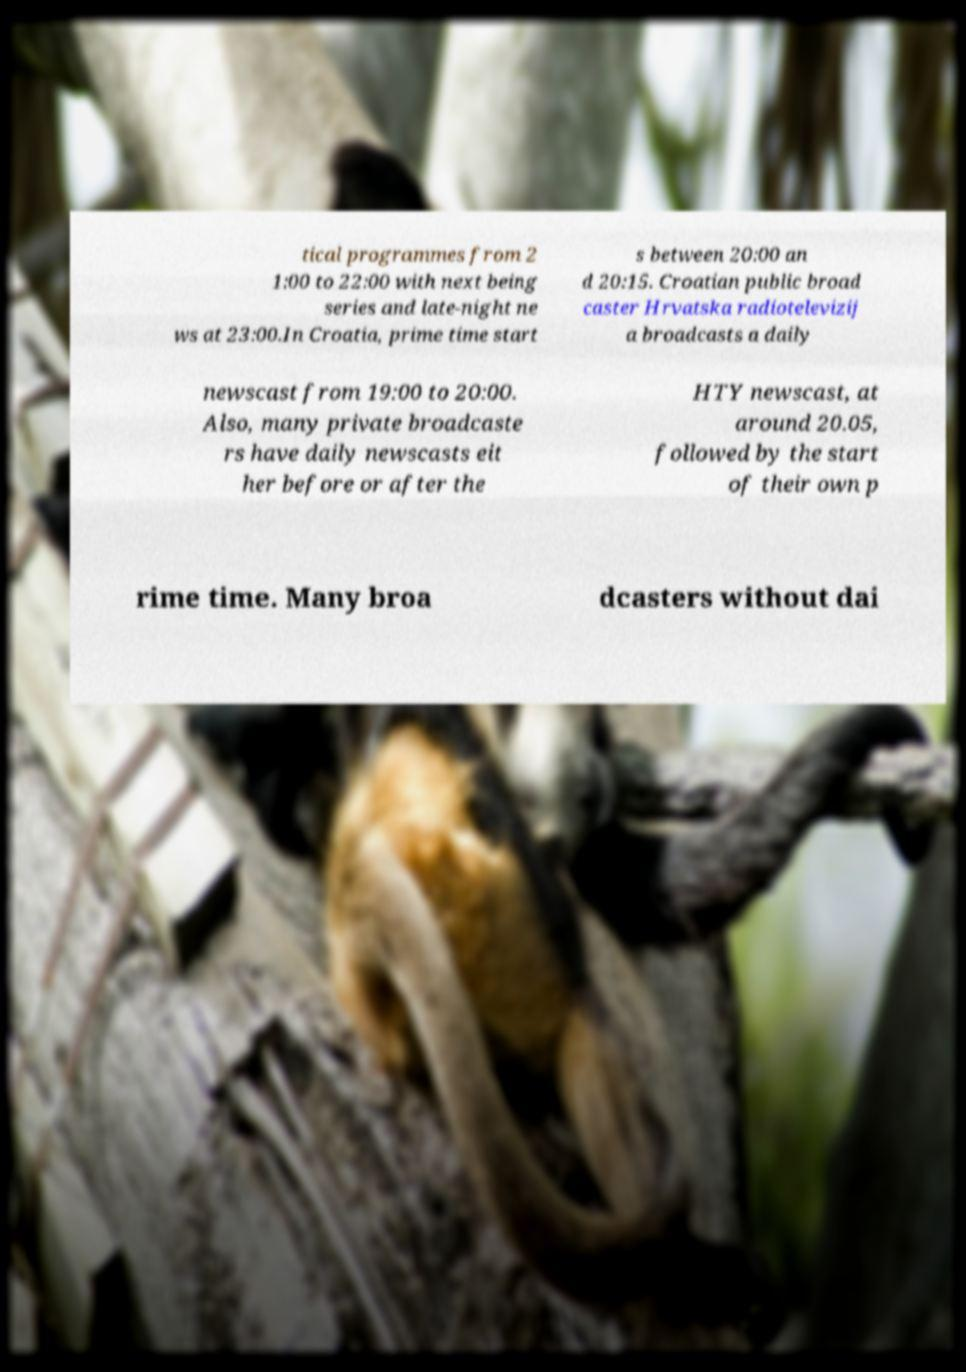Can you accurately transcribe the text from the provided image for me? tical programmes from 2 1:00 to 22:00 with next being series and late-night ne ws at 23:00.In Croatia, prime time start s between 20:00 an d 20:15. Croatian public broad caster Hrvatska radiotelevizij a broadcasts a daily newscast from 19:00 to 20:00. Also, many private broadcaste rs have daily newscasts eit her before or after the HTY newscast, at around 20.05, followed by the start of their own p rime time. Many broa dcasters without dai 